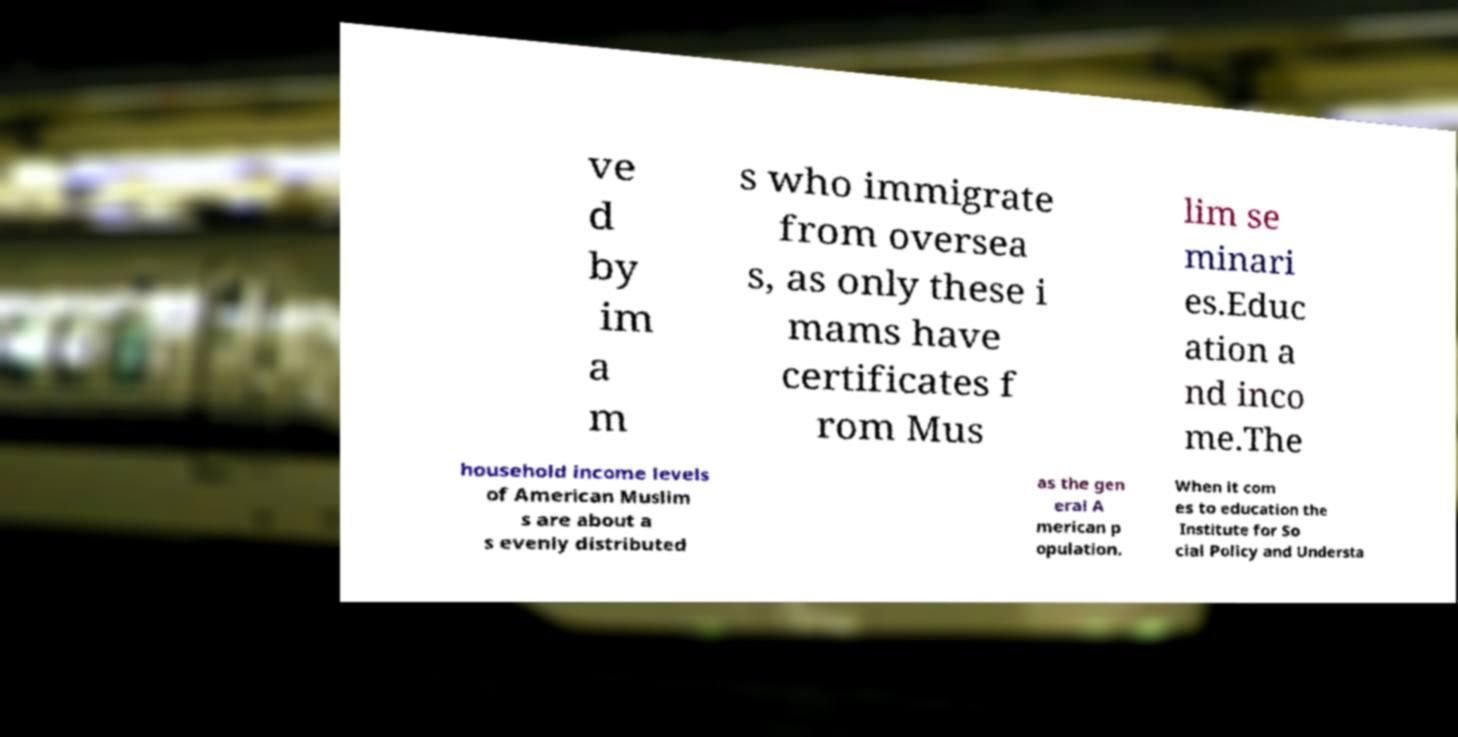Could you extract and type out the text from this image? ve d by im a m s who immigrate from oversea s, as only these i mams have certificates f rom Mus lim se minari es.Educ ation a nd inco me.The household income levels of American Muslim s are about a s evenly distributed as the gen eral A merican p opulation. When it com es to education the Institute for So cial Policy and Understa 